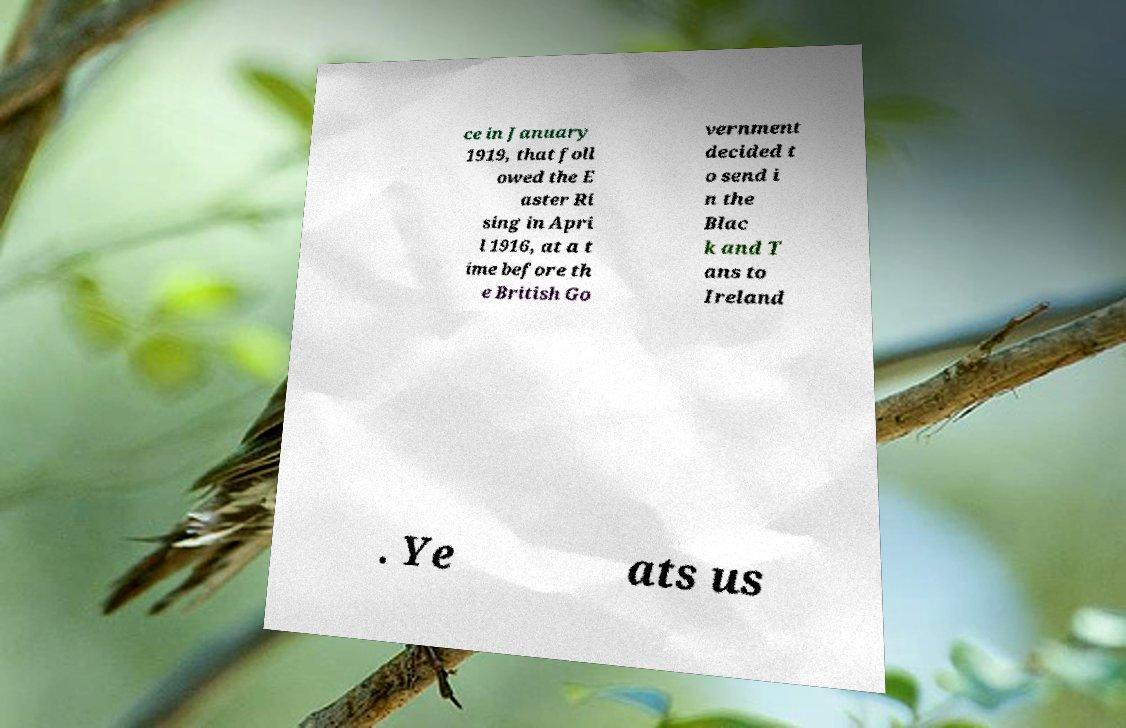Could you assist in decoding the text presented in this image and type it out clearly? ce in January 1919, that foll owed the E aster Ri sing in Apri l 1916, at a t ime before th e British Go vernment decided t o send i n the Blac k and T ans to Ireland . Ye ats us 